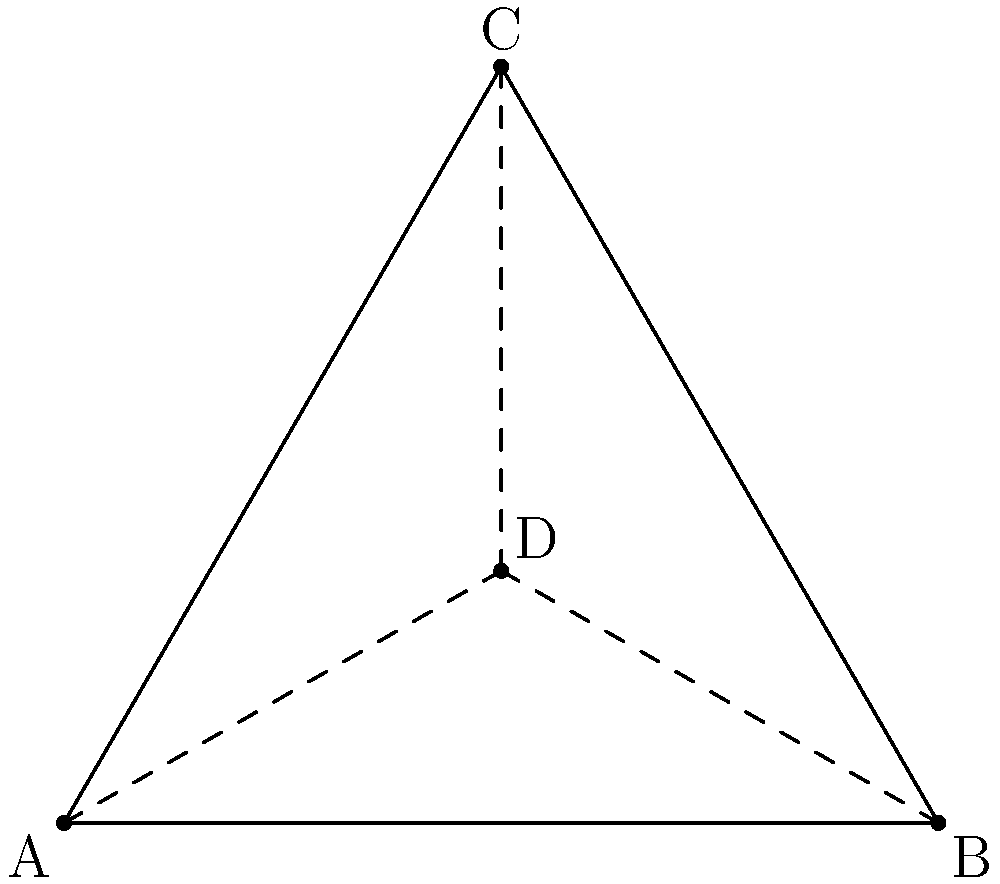In the sacred geometry of many ancient cultures, the equilateral triangle was often used as a symbol of balance and harmony. If we inscribe a circle within this equilateral triangle such that it touches all three sides, what is the ratio of the area of the inscribed circle to the area of the triangle, expressed as a decimal rounded to two places? Let's approach this step-by-step:

1) First, we need to calculate the area of the equilateral triangle. 
   If we assume the side length is $a$, the area is given by:
   $$A_{triangle} = \frac{\sqrt{3}}{4}a^2$$

2) Next, we need to find the radius of the inscribed circle. 
   For an equilateral triangle, this is given by:
   $$r = \frac{a}{2\sqrt{3}}$$

3) The area of the circle is then:
   $$A_{circle} = \pi r^2 = \pi (\frac{a}{2\sqrt{3}})^2 = \frac{\pi a^2}{12}$$

4) Now we can form the ratio:
   $$\frac{A_{circle}}{A_{triangle}} = \frac{\frac{\pi a^2}{12}}{\frac{\sqrt{3}}{4}a^2} = \frac{\pi}{3\sqrt{3}}$$

5) Calculating this:
   $$\frac{\pi}{3\sqrt{3}} \approx 0.6046$$

6) Rounding to two decimal places:
   $$0.60$$

Thus, the area of the inscribed circle is approximately 60% of the area of the equilateral triangle.
Answer: 0.60 